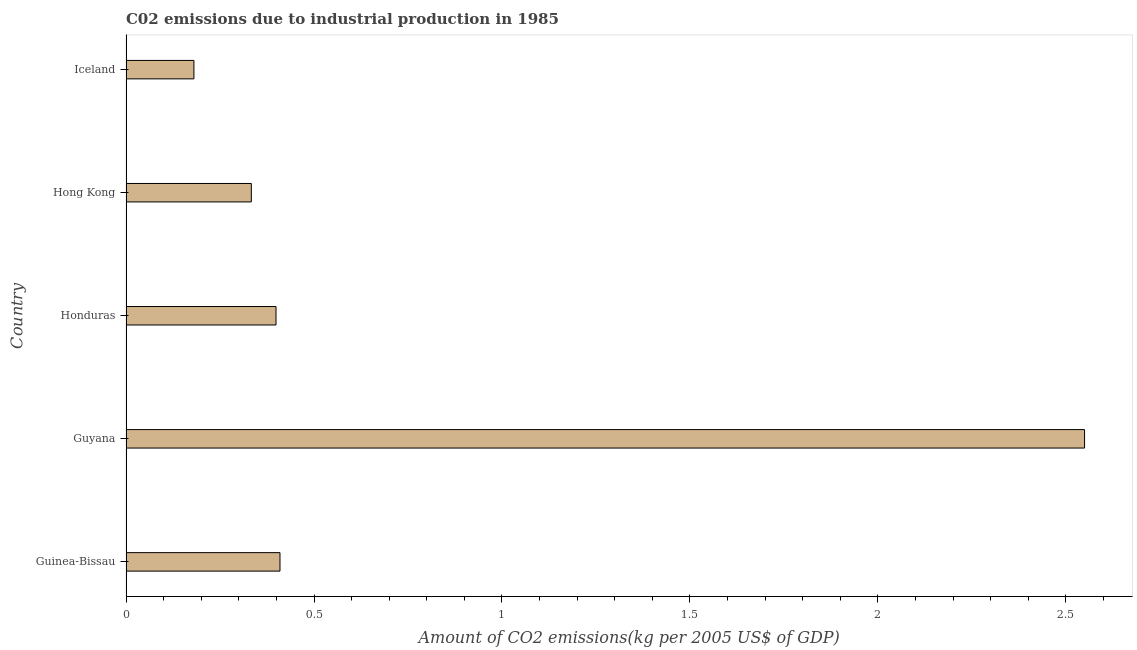Does the graph contain grids?
Your answer should be very brief. No. What is the title of the graph?
Your answer should be compact. C02 emissions due to industrial production in 1985. What is the label or title of the X-axis?
Ensure brevity in your answer.  Amount of CO2 emissions(kg per 2005 US$ of GDP). What is the amount of co2 emissions in Guyana?
Make the answer very short. 2.55. Across all countries, what is the maximum amount of co2 emissions?
Ensure brevity in your answer.  2.55. Across all countries, what is the minimum amount of co2 emissions?
Your response must be concise. 0.18. In which country was the amount of co2 emissions maximum?
Provide a short and direct response. Guyana. What is the sum of the amount of co2 emissions?
Your answer should be very brief. 3.87. What is the difference between the amount of co2 emissions in Guyana and Iceland?
Provide a succinct answer. 2.37. What is the average amount of co2 emissions per country?
Keep it short and to the point. 0.77. What is the median amount of co2 emissions?
Offer a very short reply. 0.4. Is the difference between the amount of co2 emissions in Guinea-Bissau and Honduras greater than the difference between any two countries?
Your response must be concise. No. What is the difference between the highest and the second highest amount of co2 emissions?
Your response must be concise. 2.14. What is the difference between the highest and the lowest amount of co2 emissions?
Your answer should be very brief. 2.37. In how many countries, is the amount of co2 emissions greater than the average amount of co2 emissions taken over all countries?
Offer a terse response. 1. Are all the bars in the graph horizontal?
Ensure brevity in your answer.  Yes. Are the values on the major ticks of X-axis written in scientific E-notation?
Offer a terse response. No. What is the Amount of CO2 emissions(kg per 2005 US$ of GDP) in Guinea-Bissau?
Your answer should be very brief. 0.41. What is the Amount of CO2 emissions(kg per 2005 US$ of GDP) of Guyana?
Your answer should be very brief. 2.55. What is the Amount of CO2 emissions(kg per 2005 US$ of GDP) of Honduras?
Your answer should be compact. 0.4. What is the Amount of CO2 emissions(kg per 2005 US$ of GDP) in Hong Kong?
Your answer should be compact. 0.33. What is the Amount of CO2 emissions(kg per 2005 US$ of GDP) in Iceland?
Your response must be concise. 0.18. What is the difference between the Amount of CO2 emissions(kg per 2005 US$ of GDP) in Guinea-Bissau and Guyana?
Your answer should be very brief. -2.14. What is the difference between the Amount of CO2 emissions(kg per 2005 US$ of GDP) in Guinea-Bissau and Honduras?
Make the answer very short. 0.01. What is the difference between the Amount of CO2 emissions(kg per 2005 US$ of GDP) in Guinea-Bissau and Hong Kong?
Give a very brief answer. 0.08. What is the difference between the Amount of CO2 emissions(kg per 2005 US$ of GDP) in Guinea-Bissau and Iceland?
Give a very brief answer. 0.23. What is the difference between the Amount of CO2 emissions(kg per 2005 US$ of GDP) in Guyana and Honduras?
Your answer should be very brief. 2.15. What is the difference between the Amount of CO2 emissions(kg per 2005 US$ of GDP) in Guyana and Hong Kong?
Make the answer very short. 2.22. What is the difference between the Amount of CO2 emissions(kg per 2005 US$ of GDP) in Guyana and Iceland?
Provide a succinct answer. 2.37. What is the difference between the Amount of CO2 emissions(kg per 2005 US$ of GDP) in Honduras and Hong Kong?
Give a very brief answer. 0.07. What is the difference between the Amount of CO2 emissions(kg per 2005 US$ of GDP) in Honduras and Iceland?
Your answer should be very brief. 0.22. What is the difference between the Amount of CO2 emissions(kg per 2005 US$ of GDP) in Hong Kong and Iceland?
Your answer should be very brief. 0.15. What is the ratio of the Amount of CO2 emissions(kg per 2005 US$ of GDP) in Guinea-Bissau to that in Guyana?
Keep it short and to the point. 0.16. What is the ratio of the Amount of CO2 emissions(kg per 2005 US$ of GDP) in Guinea-Bissau to that in Honduras?
Make the answer very short. 1.03. What is the ratio of the Amount of CO2 emissions(kg per 2005 US$ of GDP) in Guinea-Bissau to that in Hong Kong?
Make the answer very short. 1.23. What is the ratio of the Amount of CO2 emissions(kg per 2005 US$ of GDP) in Guinea-Bissau to that in Iceland?
Keep it short and to the point. 2.27. What is the ratio of the Amount of CO2 emissions(kg per 2005 US$ of GDP) in Guyana to that in Honduras?
Offer a very short reply. 6.39. What is the ratio of the Amount of CO2 emissions(kg per 2005 US$ of GDP) in Guyana to that in Hong Kong?
Provide a succinct answer. 7.65. What is the ratio of the Amount of CO2 emissions(kg per 2005 US$ of GDP) in Guyana to that in Iceland?
Make the answer very short. 14.12. What is the ratio of the Amount of CO2 emissions(kg per 2005 US$ of GDP) in Honduras to that in Hong Kong?
Give a very brief answer. 1.2. What is the ratio of the Amount of CO2 emissions(kg per 2005 US$ of GDP) in Honduras to that in Iceland?
Your response must be concise. 2.21. What is the ratio of the Amount of CO2 emissions(kg per 2005 US$ of GDP) in Hong Kong to that in Iceland?
Ensure brevity in your answer.  1.84. 